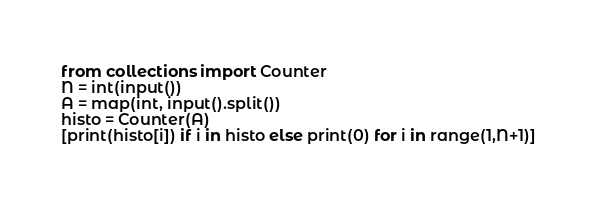Convert code to text. <code><loc_0><loc_0><loc_500><loc_500><_Python_>from collections import Counter
N = int(input())
A = map(int, input().split())
histo = Counter(A)
[print(histo[i]) if i in histo else print(0) for i in range(1,N+1)]</code> 